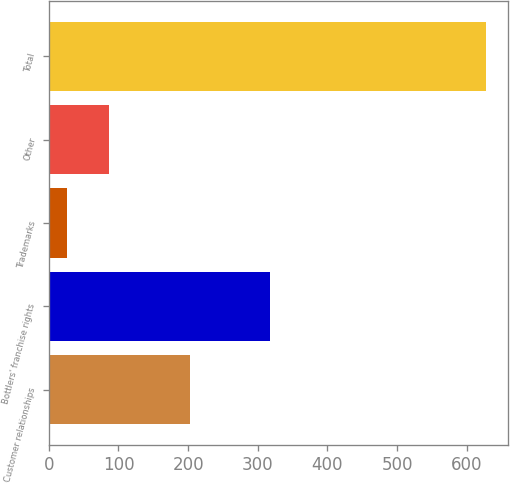Convert chart to OTSL. <chart><loc_0><loc_0><loc_500><loc_500><bar_chart><fcel>Customer relationships<fcel>Bottlers' franchise rights<fcel>Trademarks<fcel>Other<fcel>Total<nl><fcel>202<fcel>317<fcel>26<fcel>86.2<fcel>628<nl></chart> 